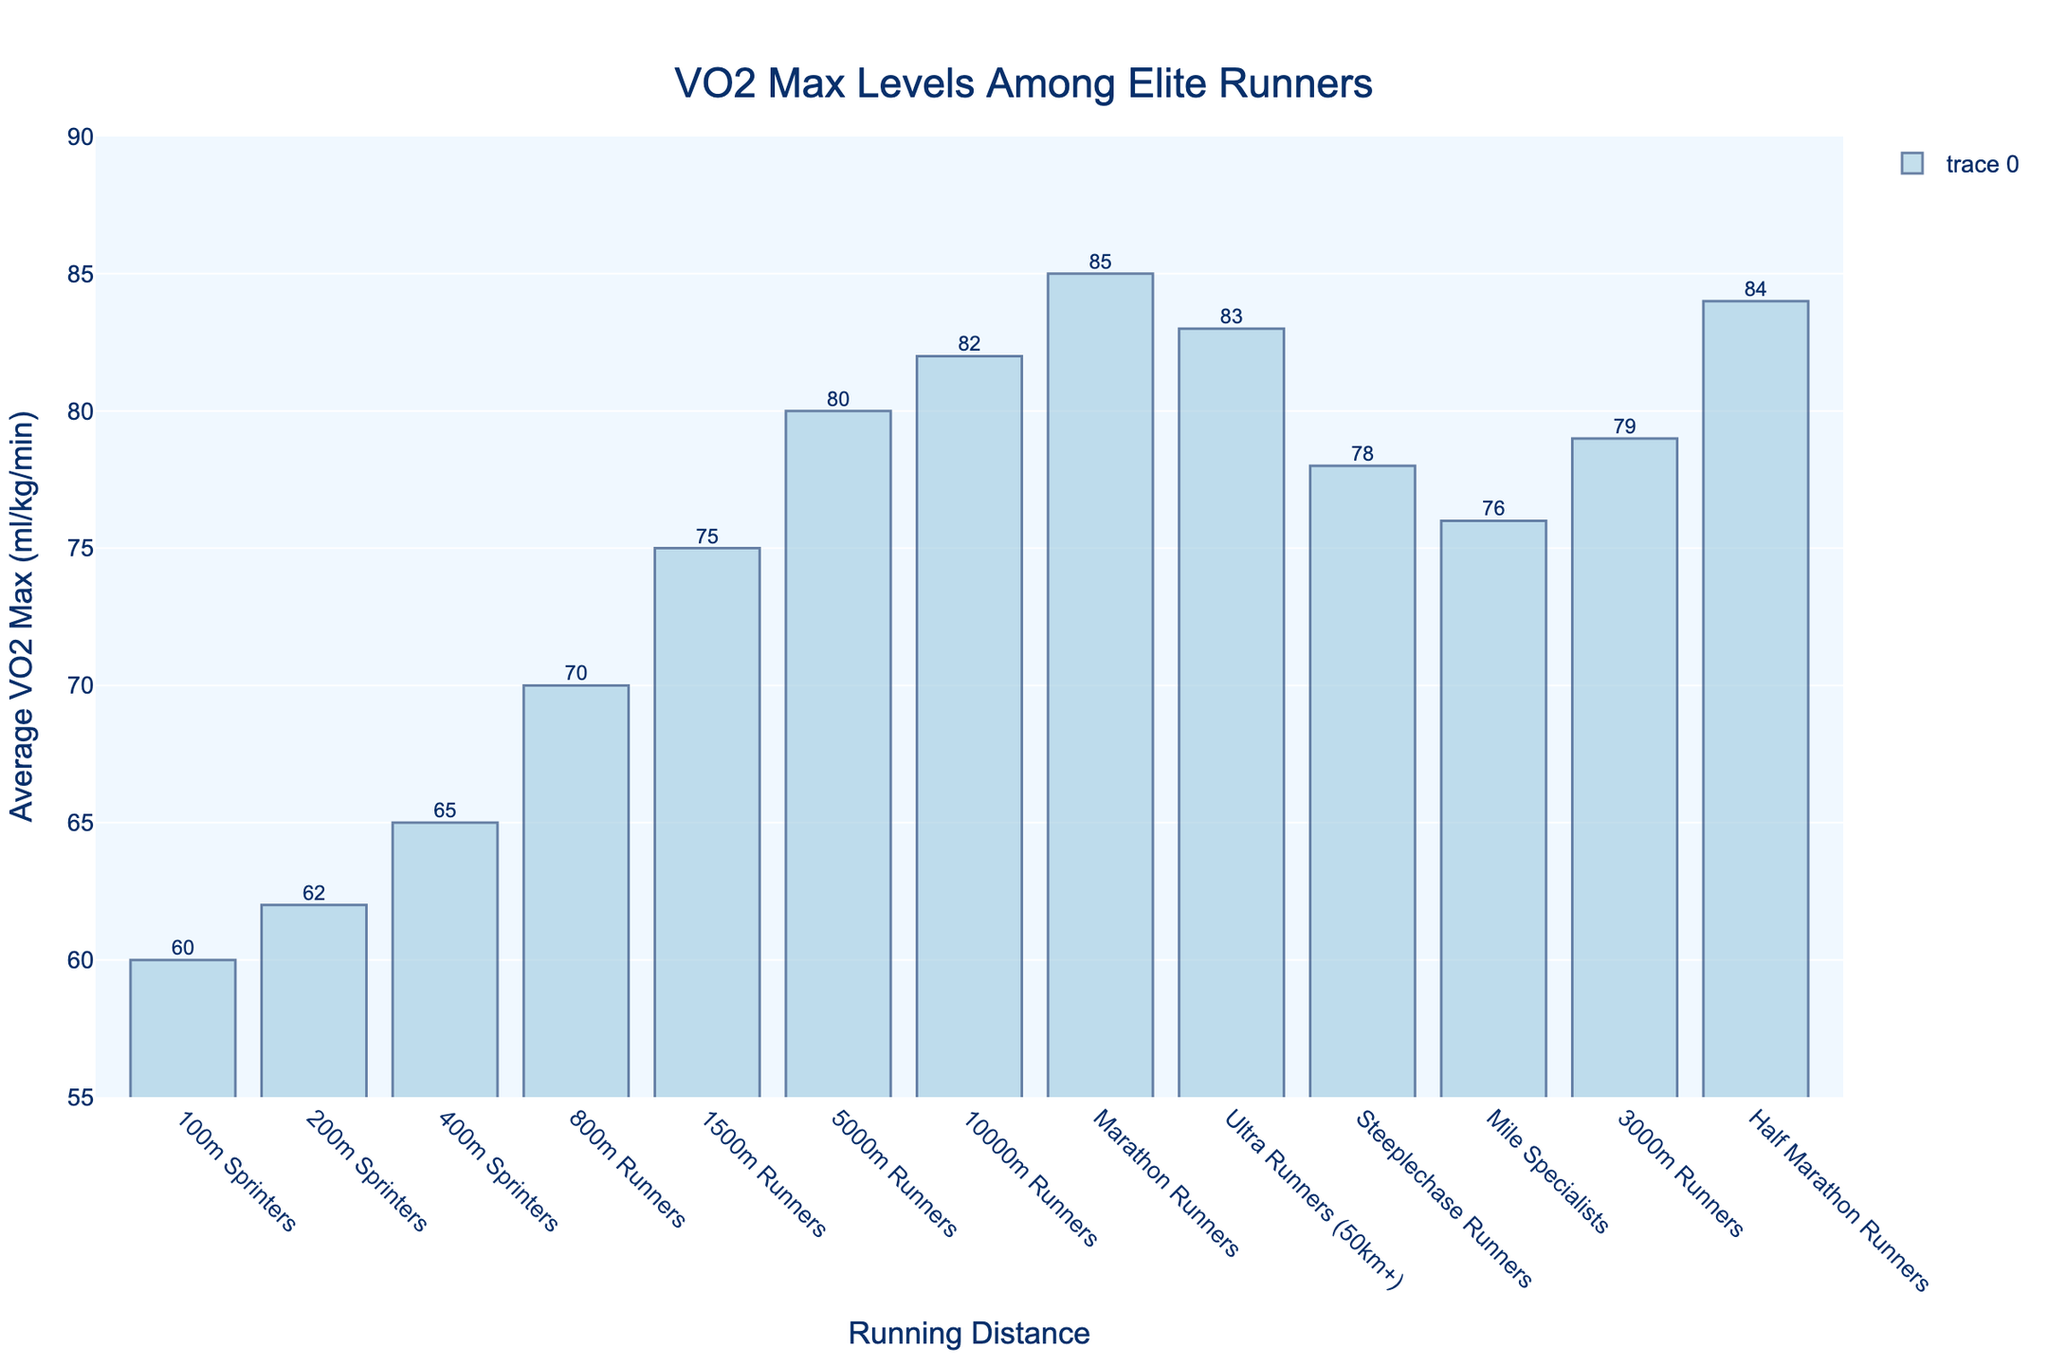Which group of runners has the highest average VO2 max? To determine which group of runners has the highest average VO2 max, look for the tallest bar in the chart. The highest average VO2 max is associated with Marathon Runners.
Answer: Marathon Runners Which group of runners has a lower average VO2 max: 5000m Runners or Steeplechase Runners? Compare the heights of the bars for 5000m Runners and Steeplechase Runners. The bar for Steeplechase Runners is lower than the bar for 5000m Runners.
Answer: Steeplechase Runners What's the difference in average VO2 max between 100m Sprinters and 800m Runners? The average VO2 max for 100m Sprinters is 60 ml/kg/min and for 800m Runners is 70 ml/kg/min. Subtract the first value from the second: 70 - 60 = 10 ml/kg/min.
Answer: 10 ml/kg/min How many groups of runners have an average VO2 max above 75 ml/kg/min? Identify the number of bars that are taller than the 75 ml/kg/min mark. The groups that meet this criterion are 5000m Runners, 10000m Runners, Marathon Runners, Ultra Runners, Steeplechase Runners, 3000m Runners, and Half Marathon Runners. Count them.
Answer: 7 Which group of runners has an average VO2 max closest to 78 ml/kg/min? Look for the bar with an average VO2 max near 78 ml/kg/min. The Steeplechase Runners have an average VO2 max of 78 ml/kg/min, matching the value directly.
Answer: Steeplechase Runners What is the average VO2 max of sprinters (100m, 200m, 400m)? Calculate the average VO2 max for the groups: (60 + 62 + 65) / 3 = 187 / 3 = 62.33 ml/kg/min.
Answer: 62.33 ml/kg/min Do Mile Specialists have a higher average VO2 max than 800m Runners? Compare the bars for Mile Specialists and 800m Runners. The Mile Specialists have an average VO2 max of 76 ml/kg/min while the 800m Runners have 70 ml/kg/min. Therefore, Mile Specialists have a higher average VO2 max.
Answer: Yes By how much does the average VO2 max of Half Marathon Runners exceed that of 1500m Runners? Subtract the average VO2 max for 1500m Runners (75 ml/kg/min) from that of Half Marathon Runners (84 ml/kg/min): 84 - 75 = 9 ml/kg/min.
Answer: 9 ml/kg/min What's the highest increase in average VO2 max between consecutive distance specialties? Calculate the differences between consecutive values: 
1. 200m-100m: 62 - 60 = 2
2. 400m-200m: 65 - 62 = 3
3. 800m-400m: 70 - 65 = 5
4. 1500m-800m: 75 - 70 = 5
5. 5000m-1500m: 80 - 75 = 5
6. 10000m-5000m: 82 - 80 = 2
7. Marathon-10000m: 85 - 82 = 3
8. Ultra- Marathon: 83 - 85 = -2
9. 3000m-Half Marathon: 79 - 84 = -5
10. Steeplechase-Ultra: 78 - 83 = -5
The highest increase is between 400m-800m, 800m-1500m, and 1500m-5000m, all showing an increase of 5 ml/kg/min.
Answer: 5 ml/kg/min 